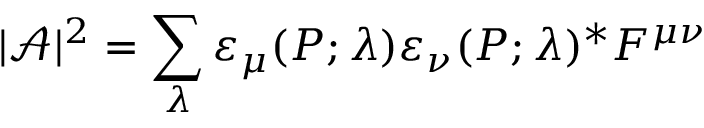Convert formula to latex. <formula><loc_0><loc_0><loc_500><loc_500>| { \mathcal { A } } | ^ { 2 } = \sum _ { \lambda } \varepsilon _ { \mu } ( P ; \lambda ) \varepsilon _ { \nu } ( P ; \lambda ) ^ { * } F ^ { \mu \nu }</formula> 